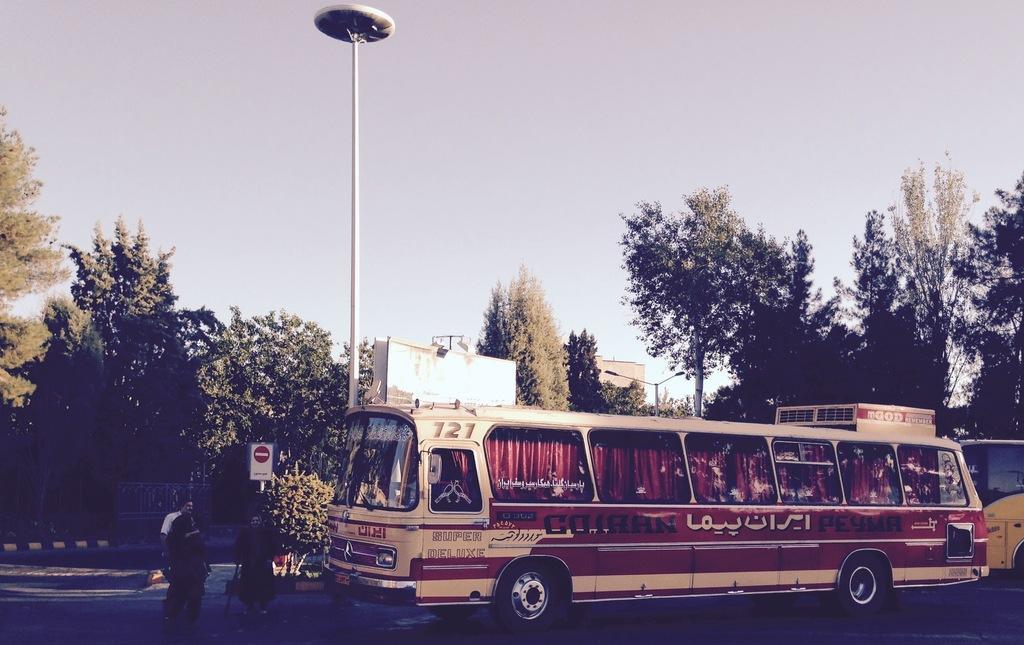Could you give a brief overview of what you see in this image? This is an outside view. On right side, I can see a bus and some other vehicle on the road. On the left side, I can see three persons are walking on the road. In the background there are some trees, poles and also I can see a building. On the top of the image I can see the sky. 